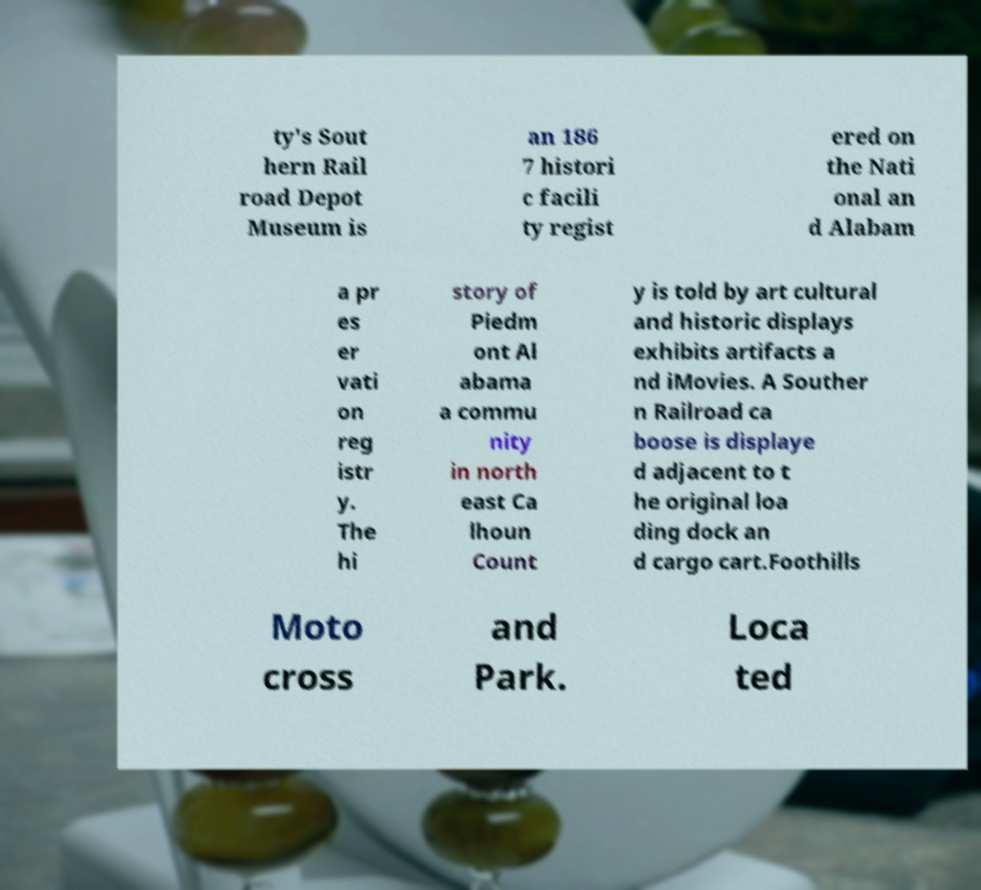Could you assist in decoding the text presented in this image and type it out clearly? ty's Sout hern Rail road Depot Museum is an 186 7 histori c facili ty regist ered on the Nati onal an d Alabam a pr es er vati on reg istr y. The hi story of Piedm ont Al abama a commu nity in north east Ca lhoun Count y is told by art cultural and historic displays exhibits artifacts a nd iMovies. A Souther n Railroad ca boose is displaye d adjacent to t he original loa ding dock an d cargo cart.Foothills Moto cross and Park. Loca ted 